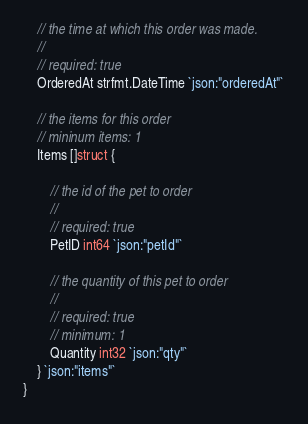<code> <loc_0><loc_0><loc_500><loc_500><_Go_>
	// the time at which this order was made.
	//
	// required: true
	OrderedAt strfmt.DateTime `json:"orderedAt"`

	// the items for this order
	// mininum items: 1
	Items []struct {

		// the id of the pet to order
		//
		// required: true
		PetID int64 `json:"petId"`

		// the quantity of this pet to order
		//
		// required: true
		// minimum: 1
		Quantity int32 `json:"qty"`
	} `json:"items"`
}
</code> 